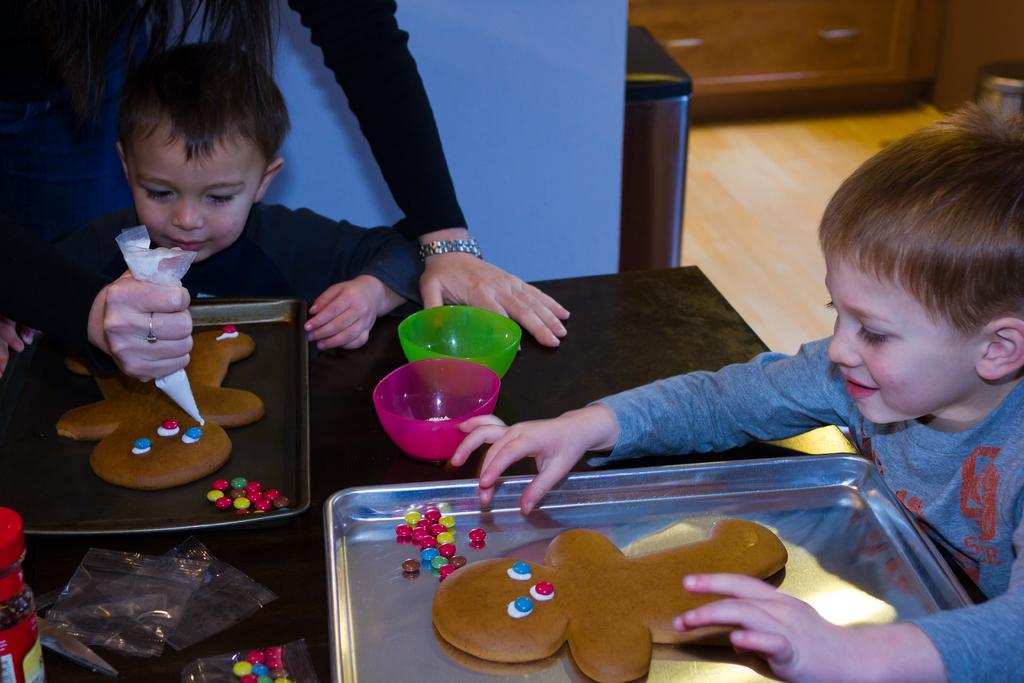How many children are in the image? There are two children in the image. What are the children doing in the image? The children are sitting in front of a table. Who is standing beside the children? There is a person standing beside the children. What can be found on the table in the image? There are bowls and a tray on the table. What is in the tray on the table? There is a cookie in the tray on the table. What type of receipt is the father holding in the image? There is no father or receipt present in the image. 